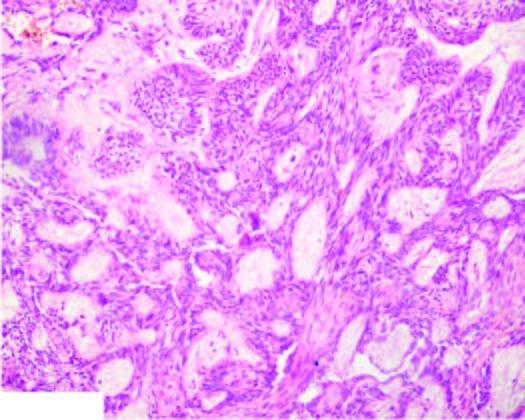what do a few areas show?
Answer the question using a single word or phrase. Central cystic change 